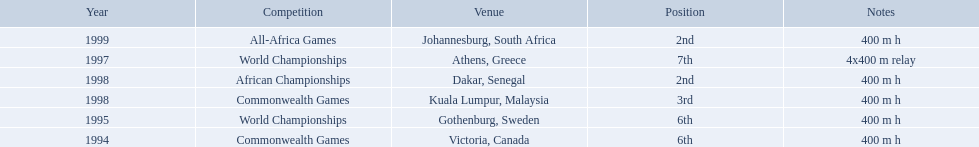What years did ken harder compete in? 1994, 1995, 1997, 1998, 1998, 1999. For the 1997 relay, what distance was ran? 4x400 m relay. 